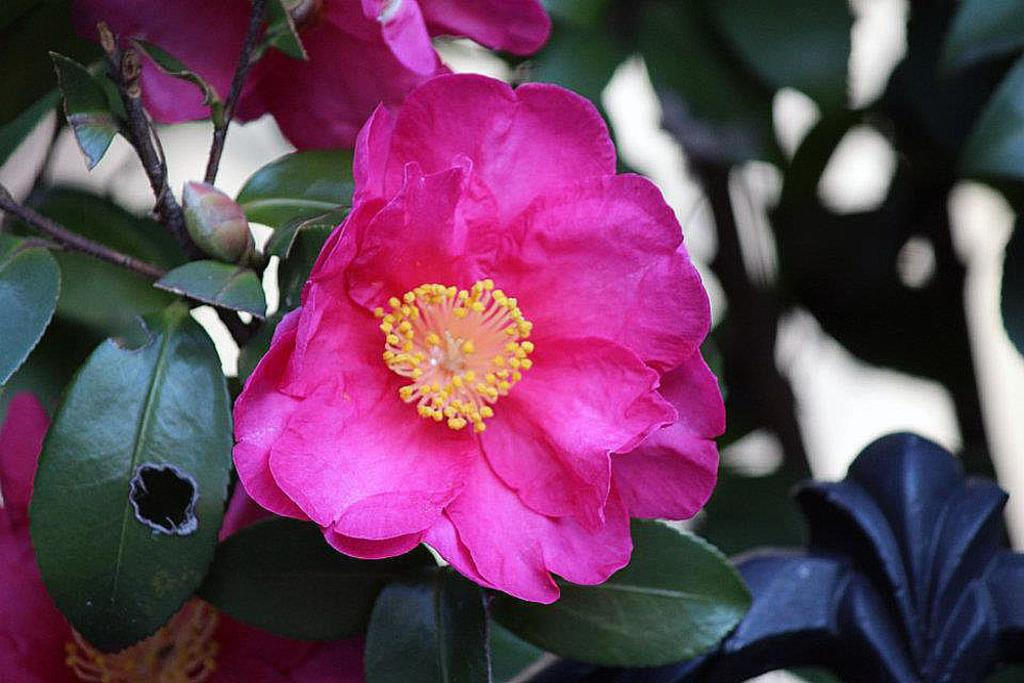What type of flowers can be seen in the image? There are two pink flowers in the image. What color are the leaves in the image? The leaves in the image are green. What type of juice is being squeezed out of the flowers in the image? There is no juice being squeezed out of the flowers in the image; it is a still image of flowers and leaves. How does the expansion of the leaves affect the growth of the flowers in the image? The image does not show any expansion of the leaves or growth of the flowers, as it is a still image. 